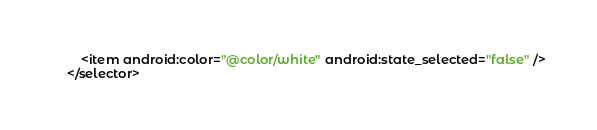<code> <loc_0><loc_0><loc_500><loc_500><_XML_>    <item android:color="@color/white" android:state_selected="false" />
</selector></code> 